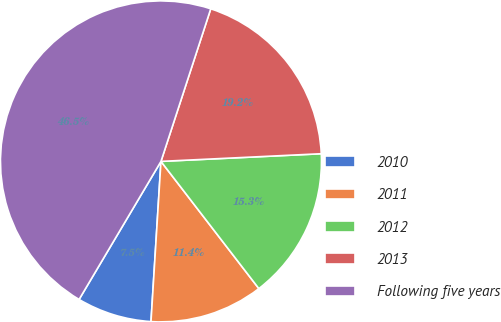Convert chart. <chart><loc_0><loc_0><loc_500><loc_500><pie_chart><fcel>2010<fcel>2011<fcel>2012<fcel>2013<fcel>Following five years<nl><fcel>7.53%<fcel>11.43%<fcel>15.32%<fcel>19.22%<fcel>46.5%<nl></chart> 